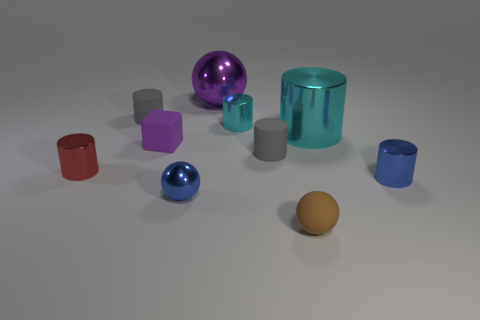What number of things are balls or tiny blue shiny things?
Keep it short and to the point. 4. How many blue things are made of the same material as the small block?
Offer a terse response. 0. There is a blue object that is the same shape as the red metallic thing; what size is it?
Give a very brief answer. Small. Are there any small gray matte things in front of the small purple object?
Make the answer very short. Yes. What is the material of the red cylinder?
Provide a short and direct response. Metal. Does the sphere that is behind the small blue ball have the same color as the cube?
Your answer should be compact. Yes. Are there any other things that are the same shape as the small purple matte object?
Make the answer very short. No. There is a large metal thing that is the same shape as the tiny red shiny object; what is its color?
Your answer should be very brief. Cyan. What is the red cylinder that is left of the cube made of?
Provide a succinct answer. Metal. What color is the big cylinder?
Make the answer very short. Cyan. 